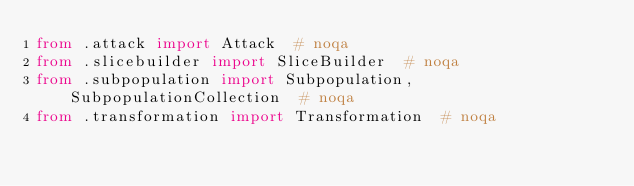<code> <loc_0><loc_0><loc_500><loc_500><_Python_>from .attack import Attack  # noqa
from .slicebuilder import SliceBuilder  # noqa
from .subpopulation import Subpopulation, SubpopulationCollection  # noqa
from .transformation import Transformation  # noqa
</code> 